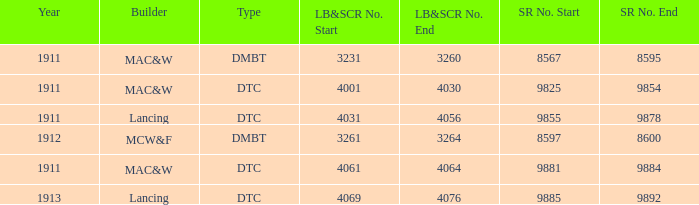Name the LB&SCR number that has SR number of 8597–8600 3261–3264. 